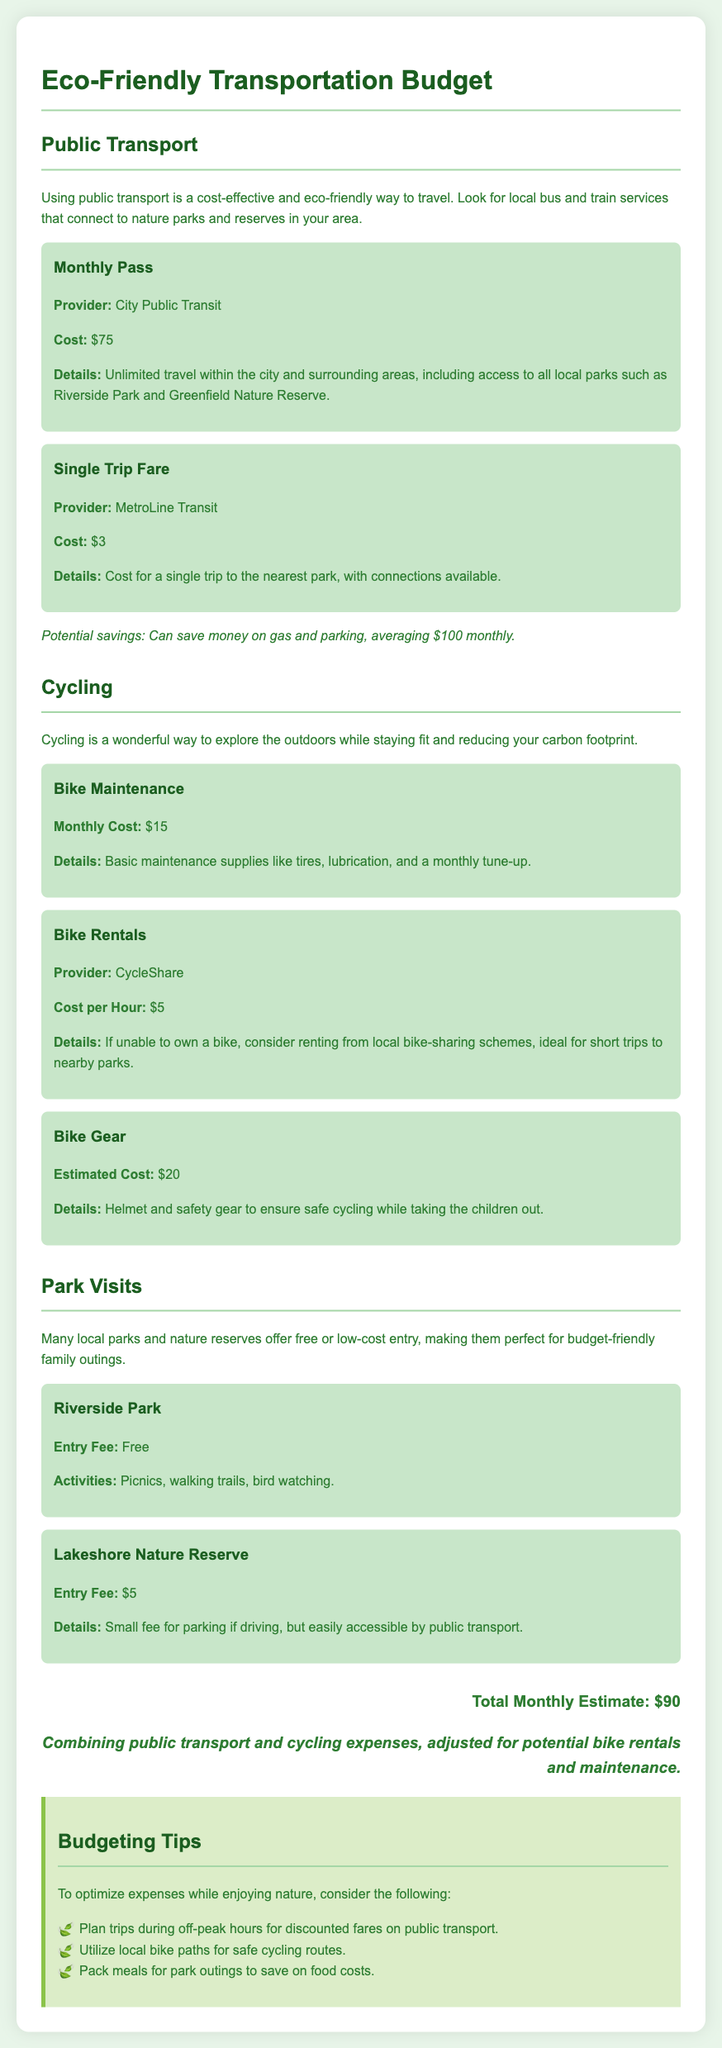what is the cost of a monthly pass for public transport? The document states that the cost for a monthly pass is $75.
Answer: $75 how much does bike maintenance cost per month? According to the document, the cost of bike maintenance is $15 per month.
Answer: $15 what is the entry fee for Lakeshore Nature Reserve? The document mentions that the entry fee for Lakeshore Nature Reserve is $5.
Answer: $5 what is the total monthly estimate for eco-friendly transportation? The document provides a total monthly estimate of $90 for transportation expenses.
Answer: $90 how much can you save on gas and parking by using public transport? The document indicates that using public transport can save money on gas and parking, averaging $100 monthly.
Answer: $100 what activities can you do at Riverside Park? The document lists activities like picnics, walking trails, and bird watching at Riverside Park.
Answer: picnics, walking trails, bird watching what is the cost per hour for bike rentals? The document specifies that the cost per hour for bike rentals is $5.
Answer: $5 what budgeting tip involves timing your trips? The document suggests planning trips during off-peak hours for discounted fares on public transport.
Answer: off-peak hours how much should you expect to spend on bike gear? The document estimates the cost for bike gear at $20.
Answer: $20 